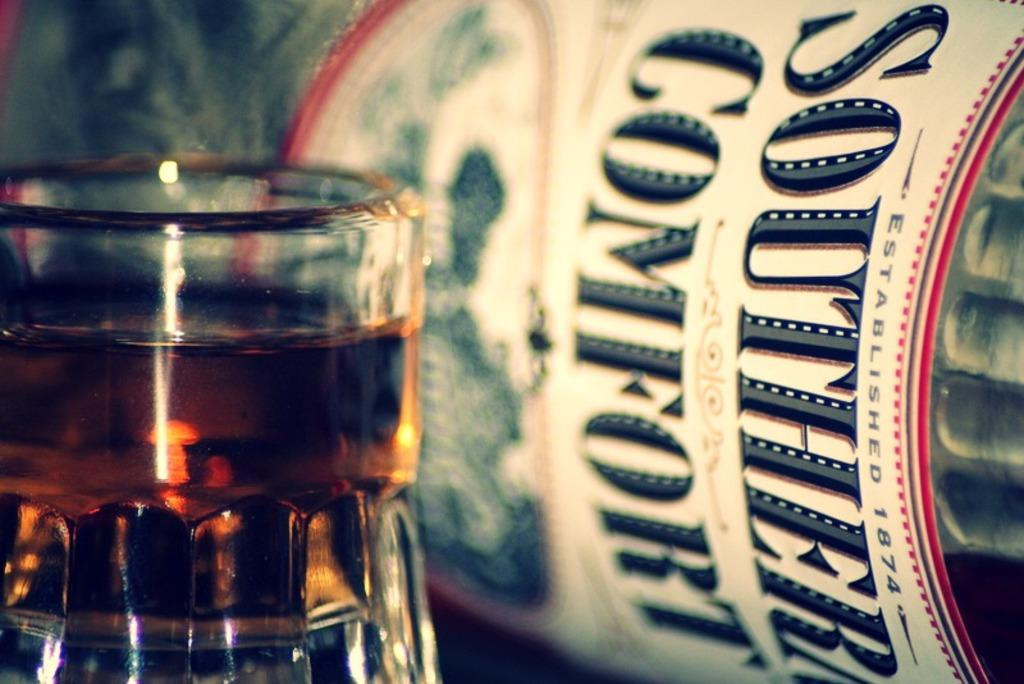<image>
Describe the image concisely. A drink glass and a bottle that says Southern Comfort. 